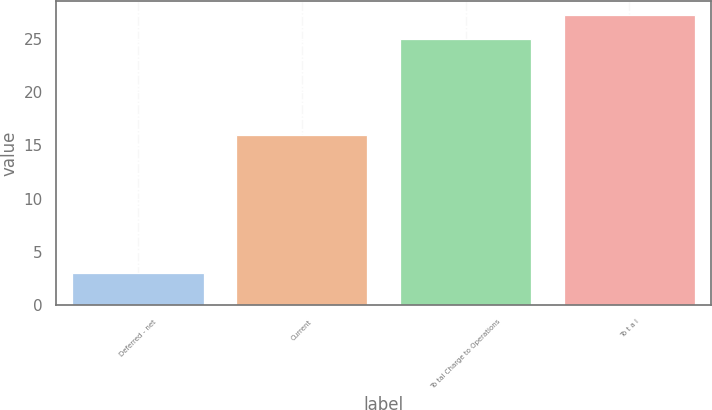Convert chart to OTSL. <chart><loc_0><loc_0><loc_500><loc_500><bar_chart><fcel>Deferred - net<fcel>Current<fcel>To tal Charge to Operations<fcel>To t a l<nl><fcel>3<fcel>16<fcel>25<fcel>27.2<nl></chart> 